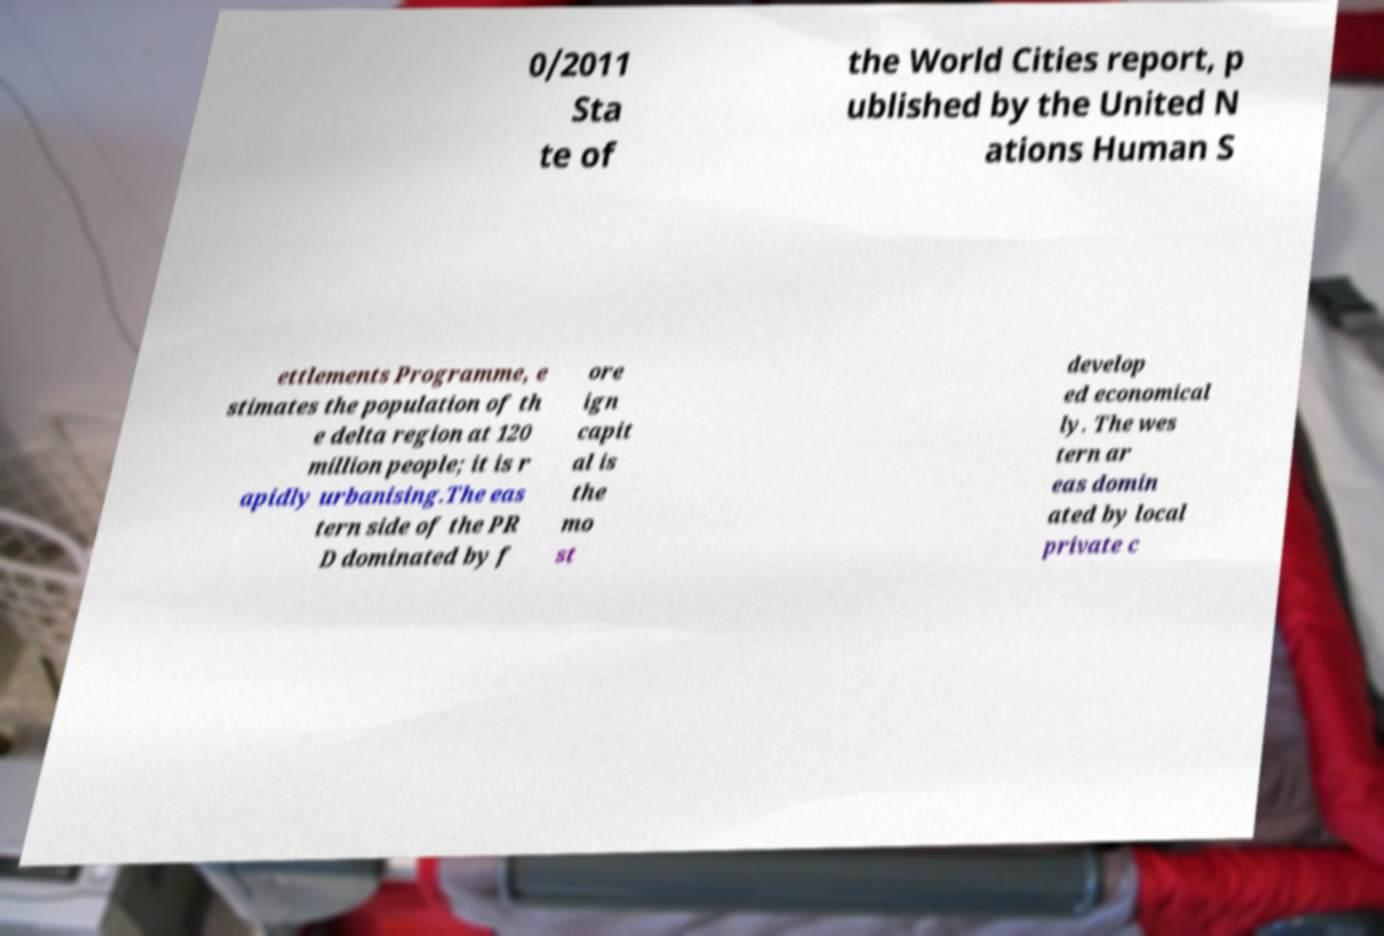Can you accurately transcribe the text from the provided image for me? 0/2011 Sta te of the World Cities report, p ublished by the United N ations Human S ettlements Programme, e stimates the population of th e delta region at 120 million people; it is r apidly urbanising.The eas tern side of the PR D dominated by f ore ign capit al is the mo st develop ed economical ly. The wes tern ar eas domin ated by local private c 